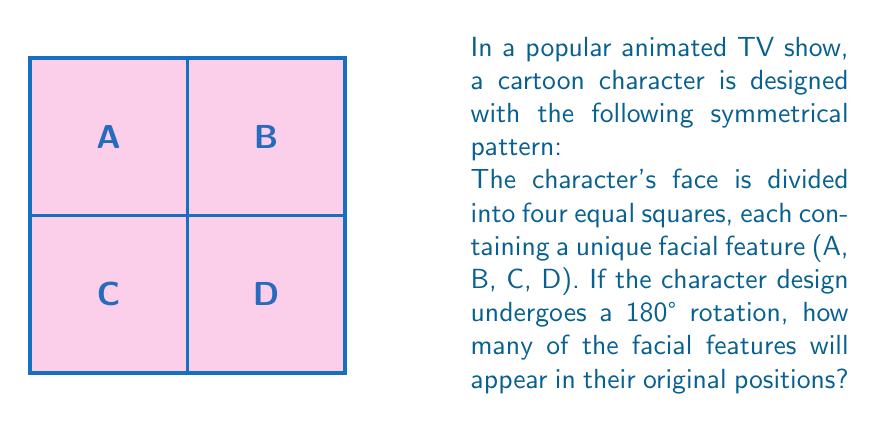What is the answer to this math problem? To solve this problem, we need to understand rotational symmetry and how it affects the position of elements in a grid.

1) First, let's visualize the 180° rotation:
   - A 180° rotation is equivalent to flipping the image both horizontally and vertically.

2) Let's analyze each square's position after rotation:
   - Square A (top-left) will move to the bottom-right
   - Square B (top-right) will move to the bottom-left
   - Square C (bottom-left) will move to the top-right
   - Square D (bottom-right) will move to the top-left

3) Now, let's compare the new positions to the original:
   - A is now where D was
   - B is now where C was
   - C is now where B was
   - D is now where A was

4) Count how many are in their original positions:
   - None of the facial features (A, B, C, D) are in their original positions after the rotation.

Therefore, 0 facial features will appear in their original positions after a 180° rotation.
Answer: 0 